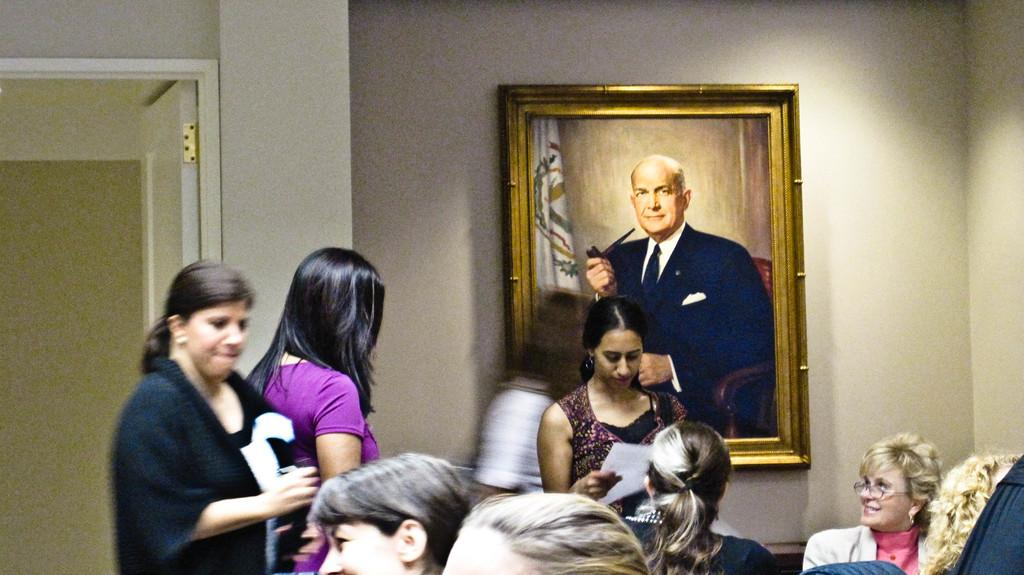How many people are in the image? There are people in the image, but the exact number is not specified. What is the girl holding in the image? The girl is holding a paper in the image. What can be seen on the wall in the image? There is a picture on the wall in the image. What architectural feature is present in the image? There is a door in the image. What is the woman doing in the image? The woman is looking at the girl in the image. What type of wax is being used to create the picture on the wall? There is no mention of wax or any specific materials used to create the picture on the wall in the image. --- Facts: 1. There is a car in the image. 2. The car is red. 3. The car has four wheels. 4. There is a road in the image. 5. The road is paved. Absurd Topics: parrot, ocean, mountain Conversation: What is the main subject of the image? The main subject of the image is a car. What color is the car? The car is red. How many wheels does the car have? The car has four wheels. What type of surface is visible in the image? There is a road in the image, and it is paved. Reasoning: Let's think step by step in order to produce the conversation. We start by identifying the main subject of the image, which is the car. Then, we describe the car's color and the number of wheels it has, which are both mentioned in the facts. Next, we acknowledge the presence of a road in the image and describe its surface as paved. Absurd Question/Answer: Can you see a parrot flying over the ocean in the image? There is no mention of a parrot, ocean, or any flying objects in the image. 